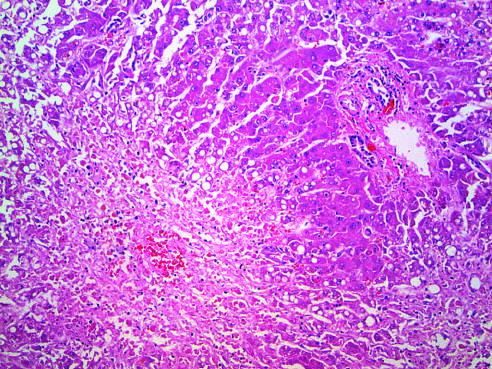what is seen in the perivenular region?
Answer the question using a single word or phrase. Confluent necrosis 